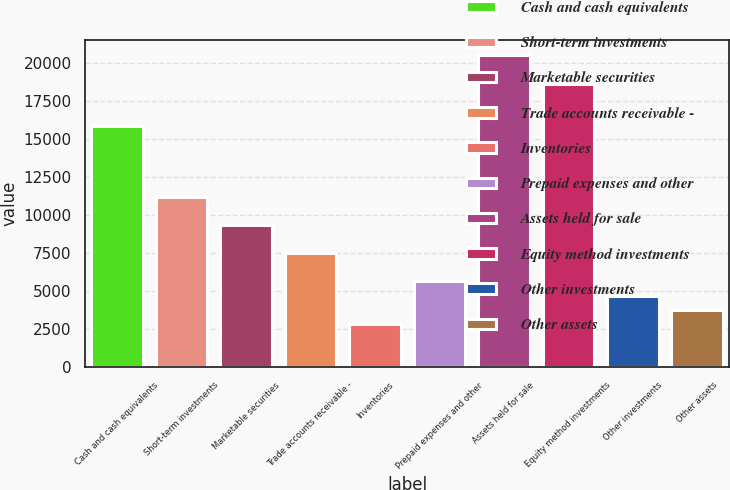<chart> <loc_0><loc_0><loc_500><loc_500><bar_chart><fcel>Cash and cash equivalents<fcel>Short-term investments<fcel>Marketable securities<fcel>Trade accounts receivable -<fcel>Inventories<fcel>Prepaid expenses and other<fcel>Assets held for sale<fcel>Equity method investments<fcel>Other investments<fcel>Other assets<nl><fcel>15836.5<fcel>11199<fcel>9344<fcel>7489<fcel>2851.5<fcel>5634<fcel>20474<fcel>18619<fcel>4706.5<fcel>3779<nl></chart> 